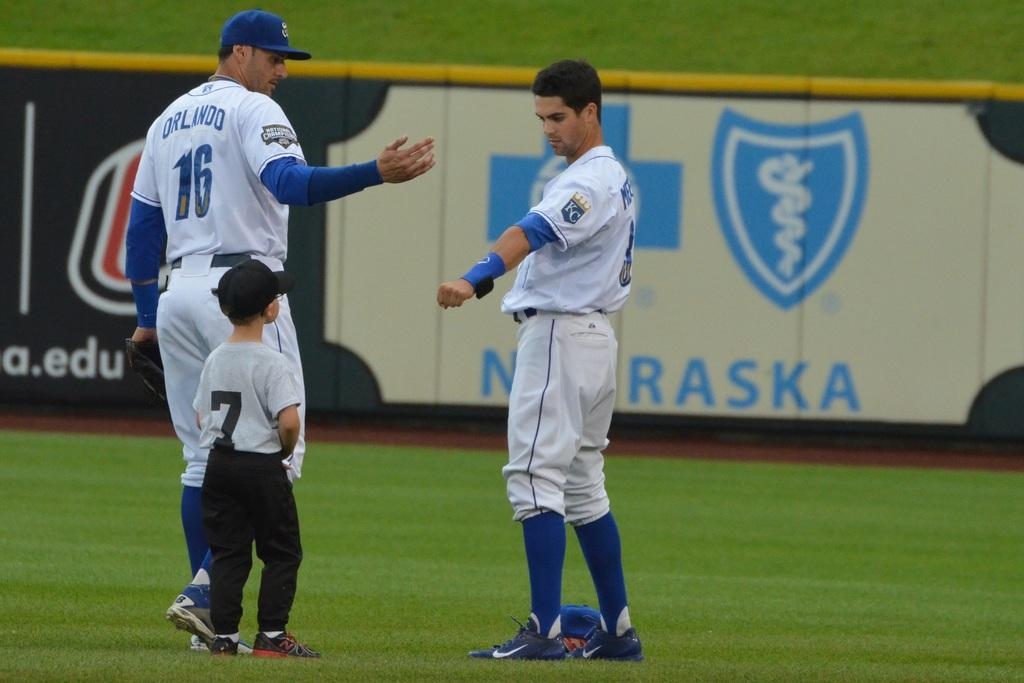<image>
Relay a brief, clear account of the picture shown. An Orlando baseball player is on the field with a boy wearing a number 7 jersey next to him. 